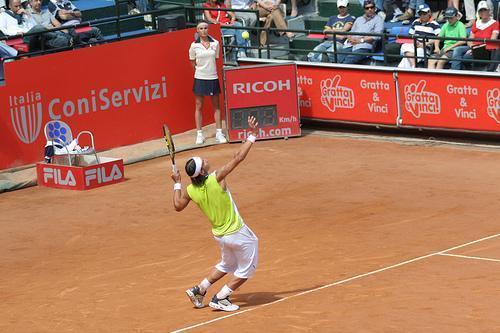How many players?
Give a very brief answer. 1. How many people are there?
Give a very brief answer. 2. How many donuts are on the plate?
Give a very brief answer. 0. 